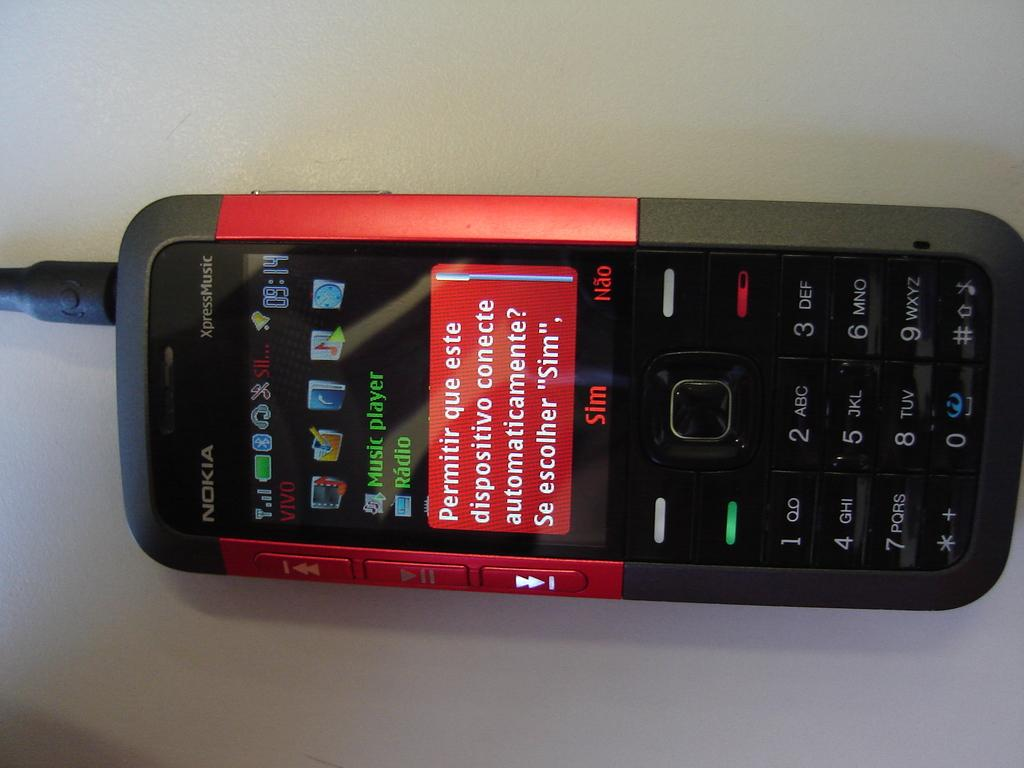<image>
Write a terse but informative summary of the picture. A black and red Nokia XpressMusic device with a small screen and keypad underneath it. 